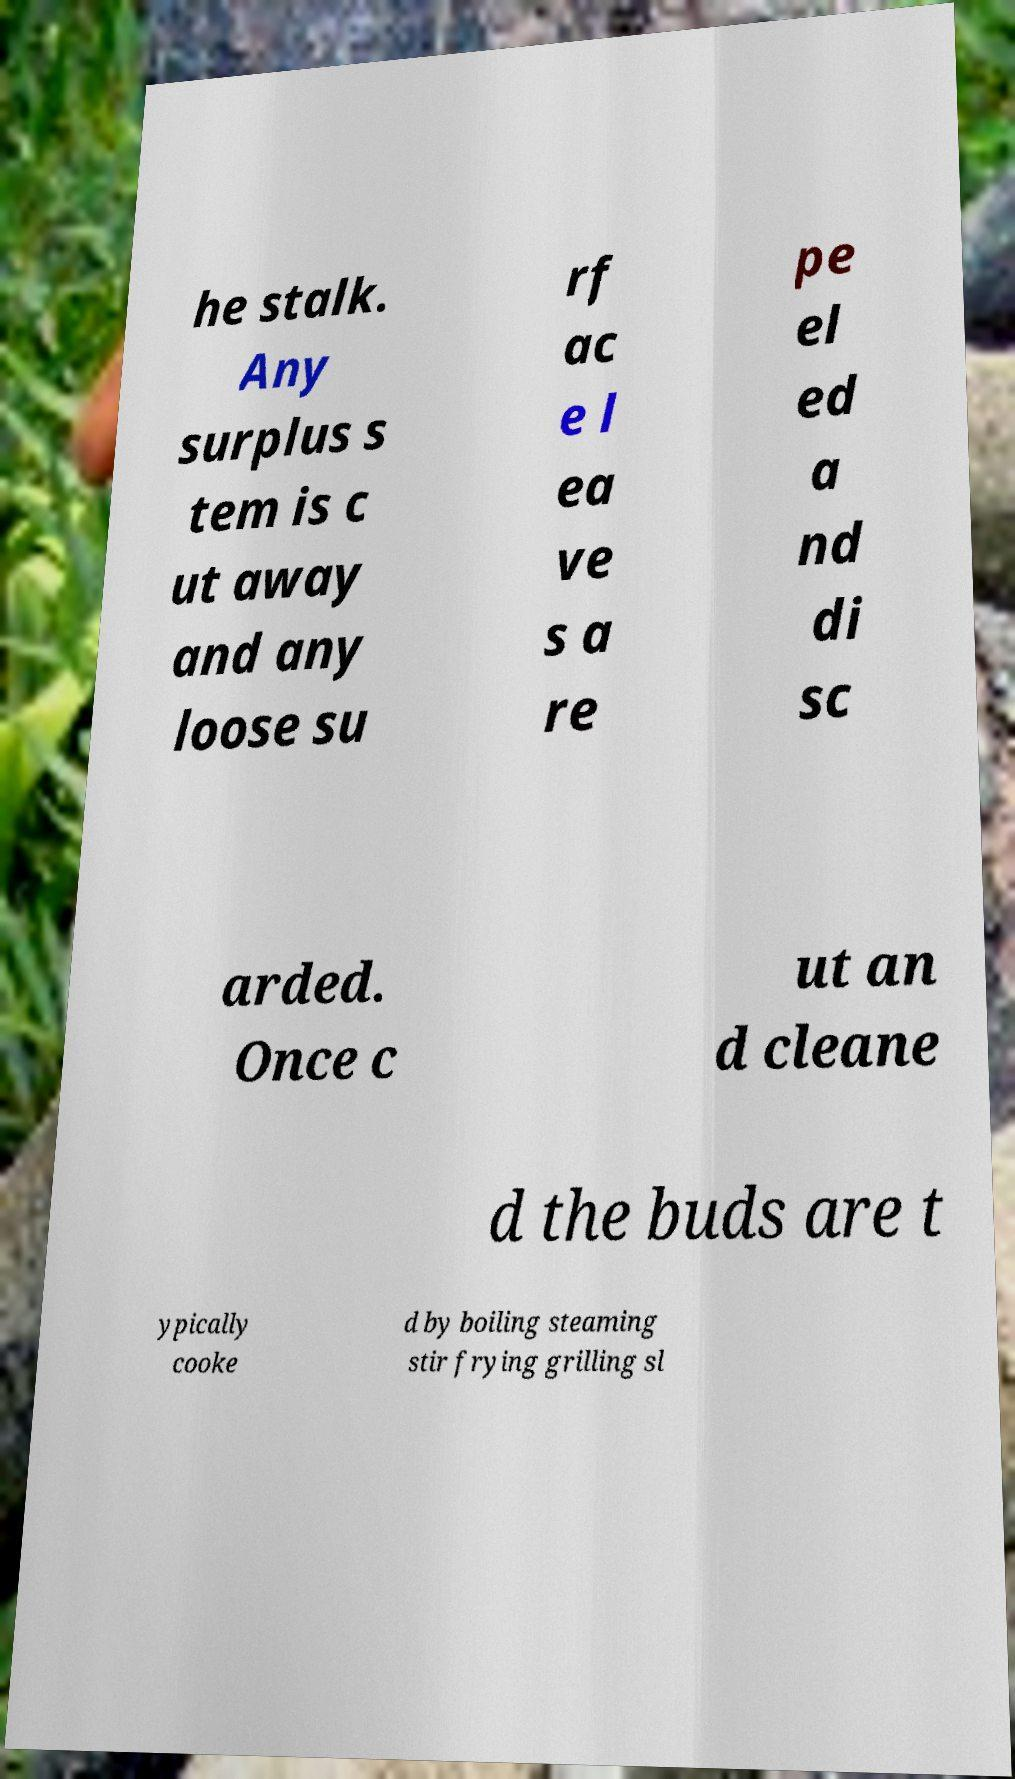I need the written content from this picture converted into text. Can you do that? he stalk. Any surplus s tem is c ut away and any loose su rf ac e l ea ve s a re pe el ed a nd di sc arded. Once c ut an d cleane d the buds are t ypically cooke d by boiling steaming stir frying grilling sl 